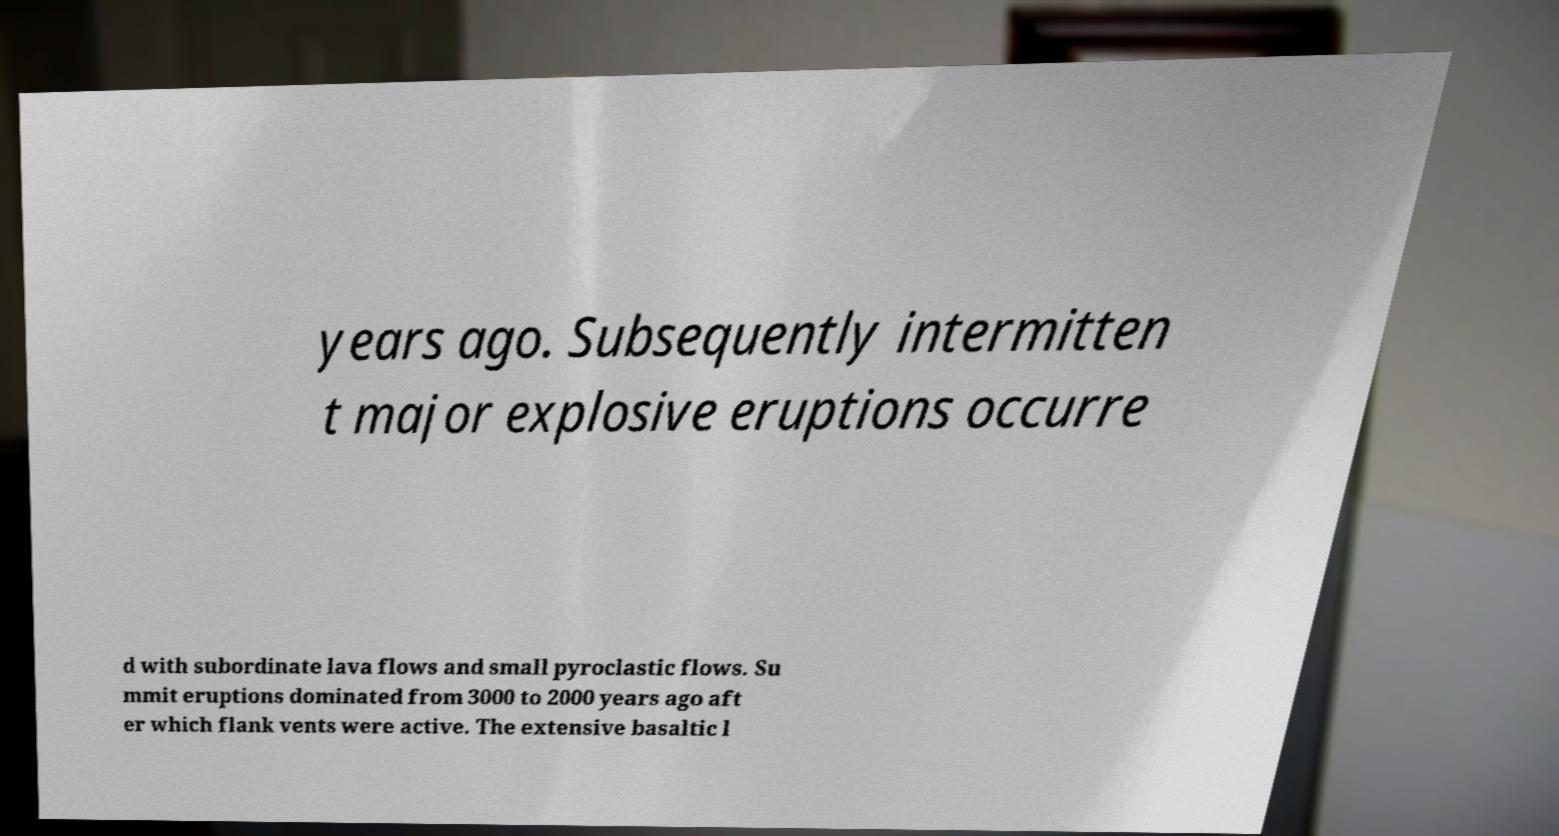What messages or text are displayed in this image? I need them in a readable, typed format. years ago. Subsequently intermitten t major explosive eruptions occurre d with subordinate lava flows and small pyroclastic flows. Su mmit eruptions dominated from 3000 to 2000 years ago aft er which flank vents were active. The extensive basaltic l 